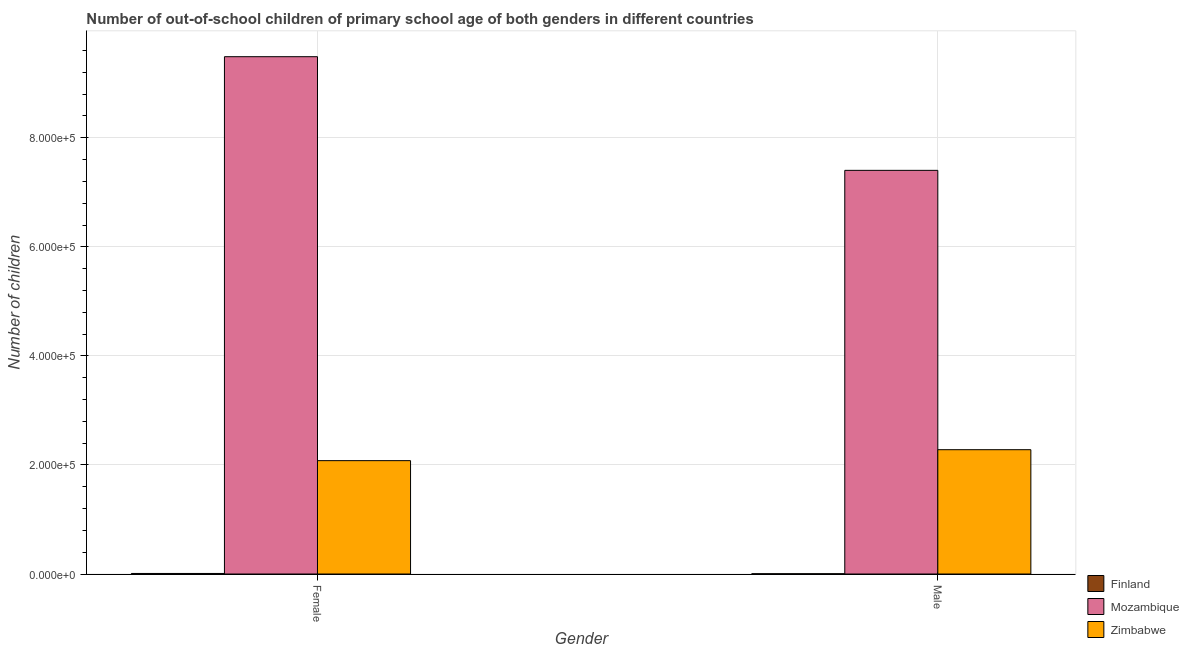Are the number of bars per tick equal to the number of legend labels?
Provide a short and direct response. Yes. Are the number of bars on each tick of the X-axis equal?
Make the answer very short. Yes. What is the label of the 2nd group of bars from the left?
Provide a short and direct response. Male. What is the number of female out-of-school students in Finland?
Provide a succinct answer. 1004. Across all countries, what is the maximum number of female out-of-school students?
Offer a very short reply. 9.49e+05. Across all countries, what is the minimum number of female out-of-school students?
Make the answer very short. 1004. In which country was the number of female out-of-school students maximum?
Provide a short and direct response. Mozambique. In which country was the number of male out-of-school students minimum?
Ensure brevity in your answer.  Finland. What is the total number of male out-of-school students in the graph?
Give a very brief answer. 9.69e+05. What is the difference between the number of female out-of-school students in Mozambique and that in Zimbabwe?
Offer a terse response. 7.41e+05. What is the difference between the number of male out-of-school students in Mozambique and the number of female out-of-school students in Zimbabwe?
Provide a short and direct response. 5.32e+05. What is the average number of male out-of-school students per country?
Provide a succinct answer. 3.23e+05. What is the difference between the number of male out-of-school students and number of female out-of-school students in Finland?
Provide a succinct answer. -533. In how many countries, is the number of female out-of-school students greater than 240000 ?
Make the answer very short. 1. What is the ratio of the number of male out-of-school students in Zimbabwe to that in Mozambique?
Ensure brevity in your answer.  0.31. Is the number of female out-of-school students in Finland less than that in Mozambique?
Provide a short and direct response. Yes. In how many countries, is the number of male out-of-school students greater than the average number of male out-of-school students taken over all countries?
Provide a short and direct response. 1. What does the 1st bar from the left in Male represents?
Keep it short and to the point. Finland. What does the 1st bar from the right in Female represents?
Your answer should be very brief. Zimbabwe. Does the graph contain any zero values?
Give a very brief answer. No. Does the graph contain grids?
Your answer should be very brief. Yes. Where does the legend appear in the graph?
Provide a short and direct response. Bottom right. How are the legend labels stacked?
Offer a terse response. Vertical. What is the title of the graph?
Give a very brief answer. Number of out-of-school children of primary school age of both genders in different countries. What is the label or title of the Y-axis?
Offer a terse response. Number of children. What is the Number of children of Finland in Female?
Offer a very short reply. 1004. What is the Number of children in Mozambique in Female?
Keep it short and to the point. 9.49e+05. What is the Number of children of Zimbabwe in Female?
Keep it short and to the point. 2.08e+05. What is the Number of children of Finland in Male?
Ensure brevity in your answer.  471. What is the Number of children in Mozambique in Male?
Provide a succinct answer. 7.40e+05. What is the Number of children of Zimbabwe in Male?
Give a very brief answer. 2.28e+05. Across all Gender, what is the maximum Number of children in Finland?
Provide a succinct answer. 1004. Across all Gender, what is the maximum Number of children of Mozambique?
Your response must be concise. 9.49e+05. Across all Gender, what is the maximum Number of children of Zimbabwe?
Offer a terse response. 2.28e+05. Across all Gender, what is the minimum Number of children of Finland?
Ensure brevity in your answer.  471. Across all Gender, what is the minimum Number of children in Mozambique?
Your answer should be very brief. 7.40e+05. Across all Gender, what is the minimum Number of children of Zimbabwe?
Keep it short and to the point. 2.08e+05. What is the total Number of children in Finland in the graph?
Ensure brevity in your answer.  1475. What is the total Number of children of Mozambique in the graph?
Offer a very short reply. 1.69e+06. What is the total Number of children of Zimbabwe in the graph?
Provide a succinct answer. 4.36e+05. What is the difference between the Number of children in Finland in Female and that in Male?
Keep it short and to the point. 533. What is the difference between the Number of children of Mozambique in Female and that in Male?
Ensure brevity in your answer.  2.08e+05. What is the difference between the Number of children of Zimbabwe in Female and that in Male?
Offer a terse response. -2.01e+04. What is the difference between the Number of children of Finland in Female and the Number of children of Mozambique in Male?
Make the answer very short. -7.39e+05. What is the difference between the Number of children of Finland in Female and the Number of children of Zimbabwe in Male?
Your answer should be compact. -2.27e+05. What is the difference between the Number of children in Mozambique in Female and the Number of children in Zimbabwe in Male?
Ensure brevity in your answer.  7.21e+05. What is the average Number of children of Finland per Gender?
Your response must be concise. 737.5. What is the average Number of children of Mozambique per Gender?
Your response must be concise. 8.44e+05. What is the average Number of children in Zimbabwe per Gender?
Make the answer very short. 2.18e+05. What is the difference between the Number of children in Finland and Number of children in Mozambique in Female?
Your answer should be very brief. -9.48e+05. What is the difference between the Number of children in Finland and Number of children in Zimbabwe in Female?
Offer a very short reply. -2.07e+05. What is the difference between the Number of children in Mozambique and Number of children in Zimbabwe in Female?
Give a very brief answer. 7.41e+05. What is the difference between the Number of children of Finland and Number of children of Mozambique in Male?
Offer a terse response. -7.40e+05. What is the difference between the Number of children in Finland and Number of children in Zimbabwe in Male?
Offer a very short reply. -2.27e+05. What is the difference between the Number of children of Mozambique and Number of children of Zimbabwe in Male?
Offer a terse response. 5.12e+05. What is the ratio of the Number of children in Finland in Female to that in Male?
Offer a very short reply. 2.13. What is the ratio of the Number of children of Mozambique in Female to that in Male?
Your answer should be very brief. 1.28. What is the ratio of the Number of children in Zimbabwe in Female to that in Male?
Your answer should be compact. 0.91. What is the difference between the highest and the second highest Number of children in Finland?
Provide a short and direct response. 533. What is the difference between the highest and the second highest Number of children of Mozambique?
Your answer should be compact. 2.08e+05. What is the difference between the highest and the second highest Number of children in Zimbabwe?
Your answer should be compact. 2.01e+04. What is the difference between the highest and the lowest Number of children in Finland?
Provide a short and direct response. 533. What is the difference between the highest and the lowest Number of children in Mozambique?
Keep it short and to the point. 2.08e+05. What is the difference between the highest and the lowest Number of children in Zimbabwe?
Make the answer very short. 2.01e+04. 